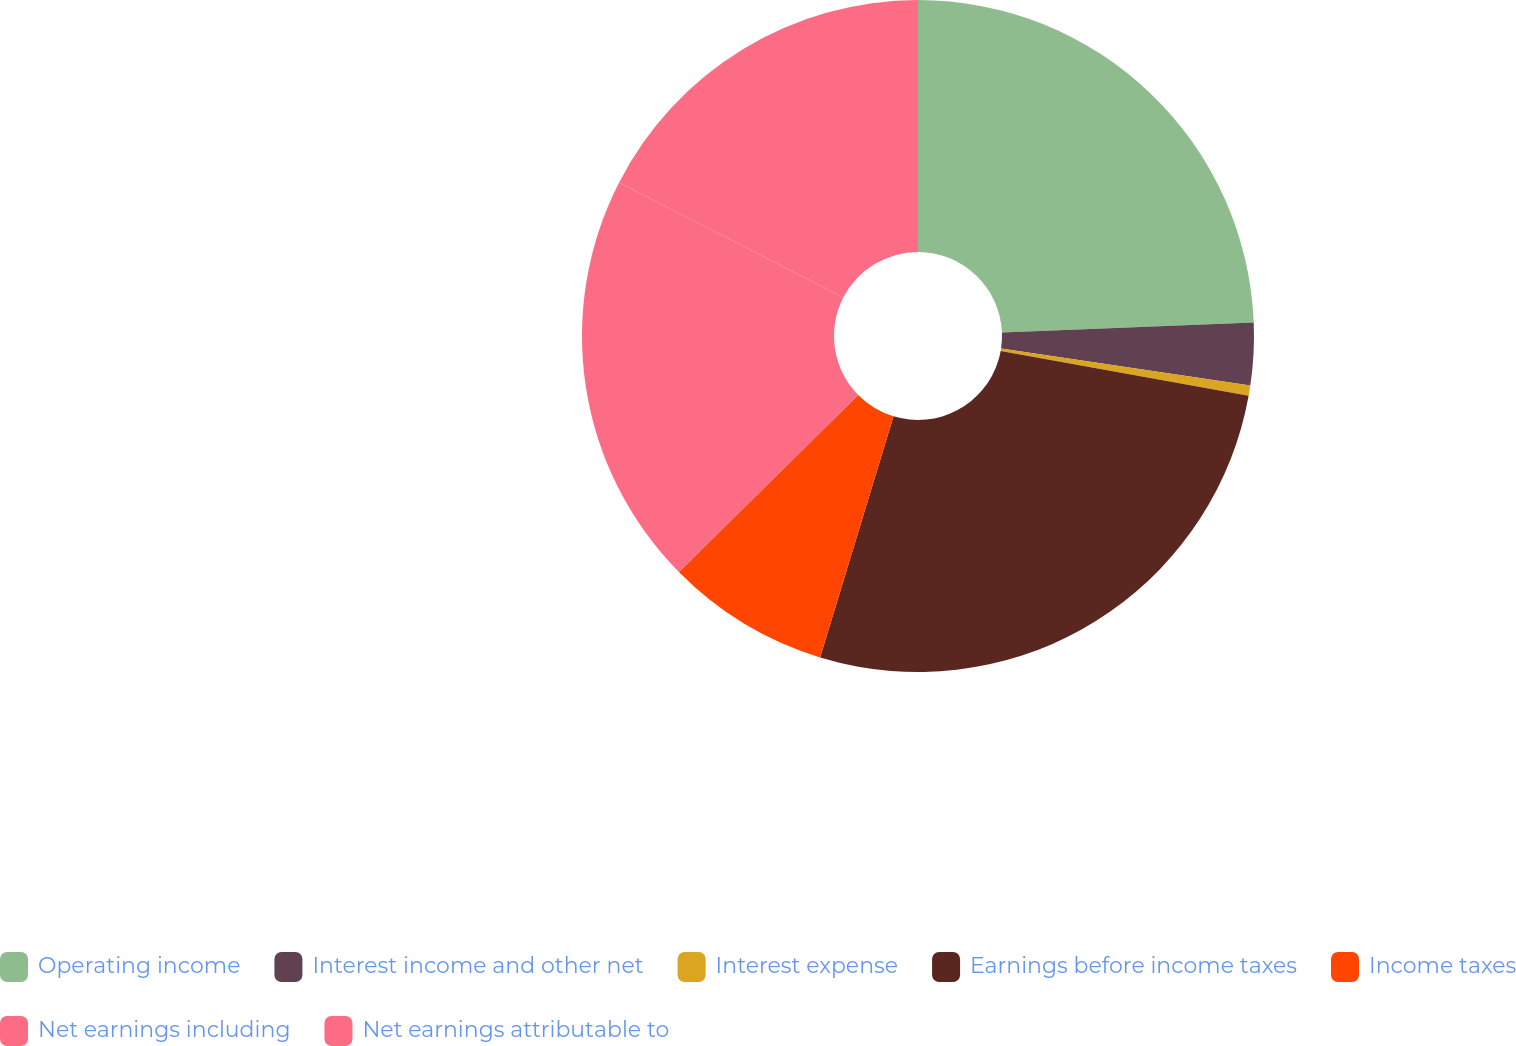Convert chart to OTSL. <chart><loc_0><loc_0><loc_500><loc_500><pie_chart><fcel>Operating income<fcel>Interest income and other net<fcel>Interest expense<fcel>Earnings before income taxes<fcel>Income taxes<fcel>Net earnings including<fcel>Net earnings attributable to<nl><fcel>24.36%<fcel>3.0%<fcel>0.49%<fcel>26.86%<fcel>7.9%<fcel>19.95%<fcel>17.45%<nl></chart> 